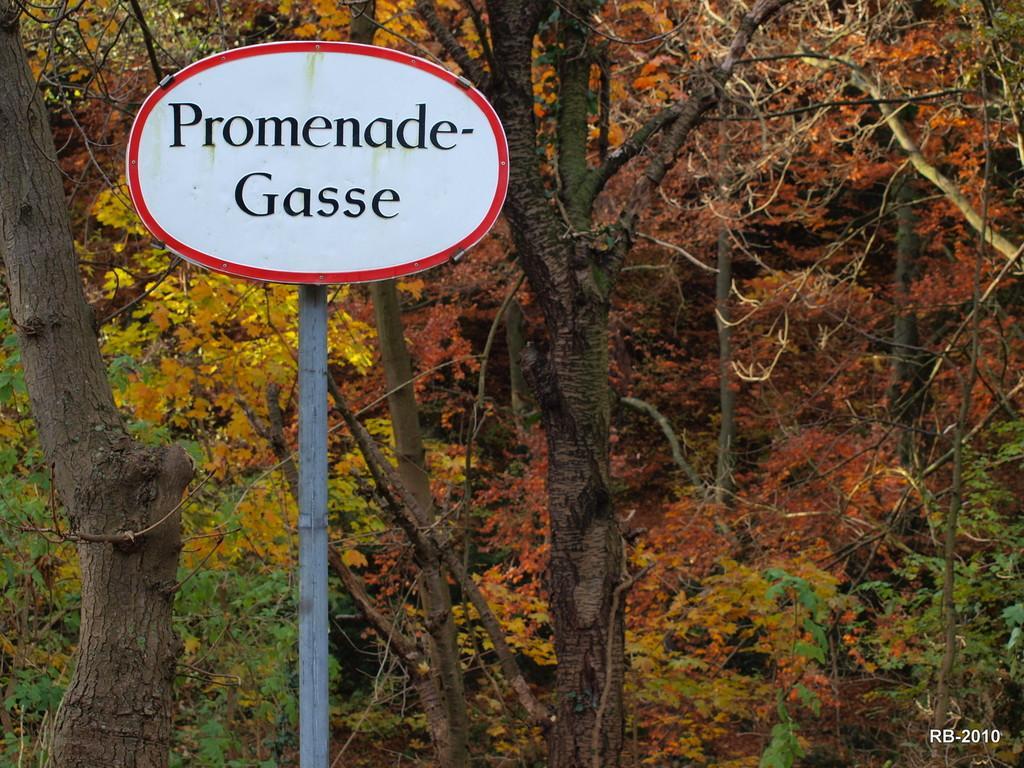How would you summarize this image in a sentence or two? This picture is clicked outside. On the left there is a white color board attached to the pole and we can see the text on the board. In the background we can see the trees and plants. In the bottom right corner we can see the text and the numbers on the image. 